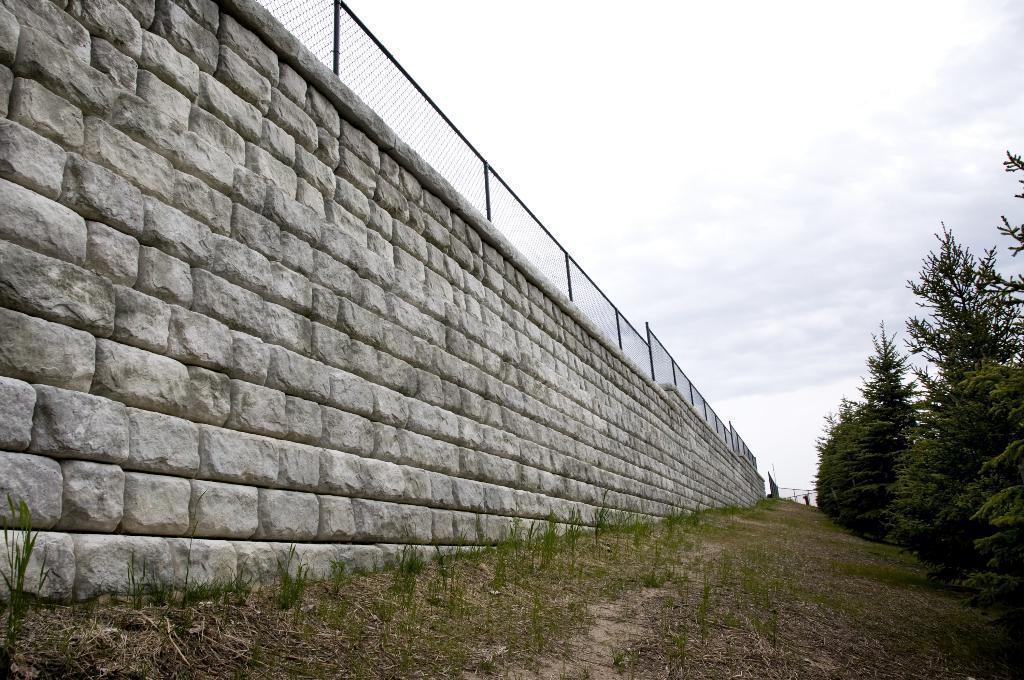What type of wall is shown in the image? There is a wall made with stones in the image. What is attached to the wall? There is a fence on the wall. What can be seen on the right side of the image? There is a group of trees on the right side of the image. What other living organisms are present in the image? There are plants in the image. What is visible in the background of the image? The sky is visible in the image. How would you describe the weather based on the sky? The sky appears cloudy in the image. What type of knee injury can be seen in the image? There is no knee injury present in the image. What kind of lace is used to decorate the wall in the image? There is no lace used to decorate the wall in the image; it is made of stones. 